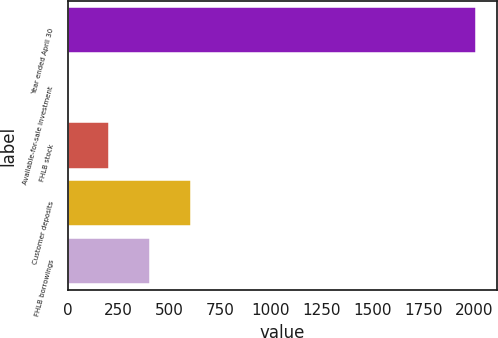Convert chart to OTSL. <chart><loc_0><loc_0><loc_500><loc_500><bar_chart><fcel>Year ended April 30<fcel>Available-for-sale investment<fcel>FHLB stock<fcel>Customer deposits<fcel>FHLB borrowings<nl><fcel>2011<fcel>2<fcel>202.9<fcel>604.7<fcel>403.8<nl></chart> 